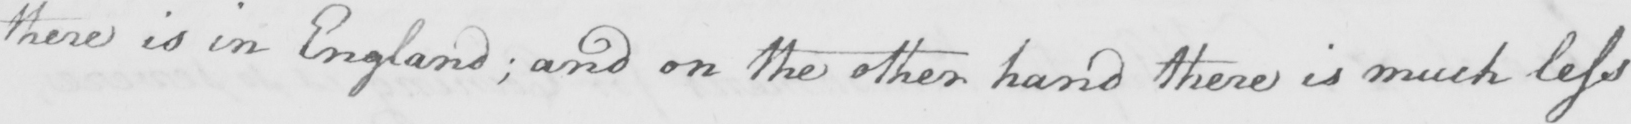What does this handwritten line say? there is in England ; and on the other hand there is much less 